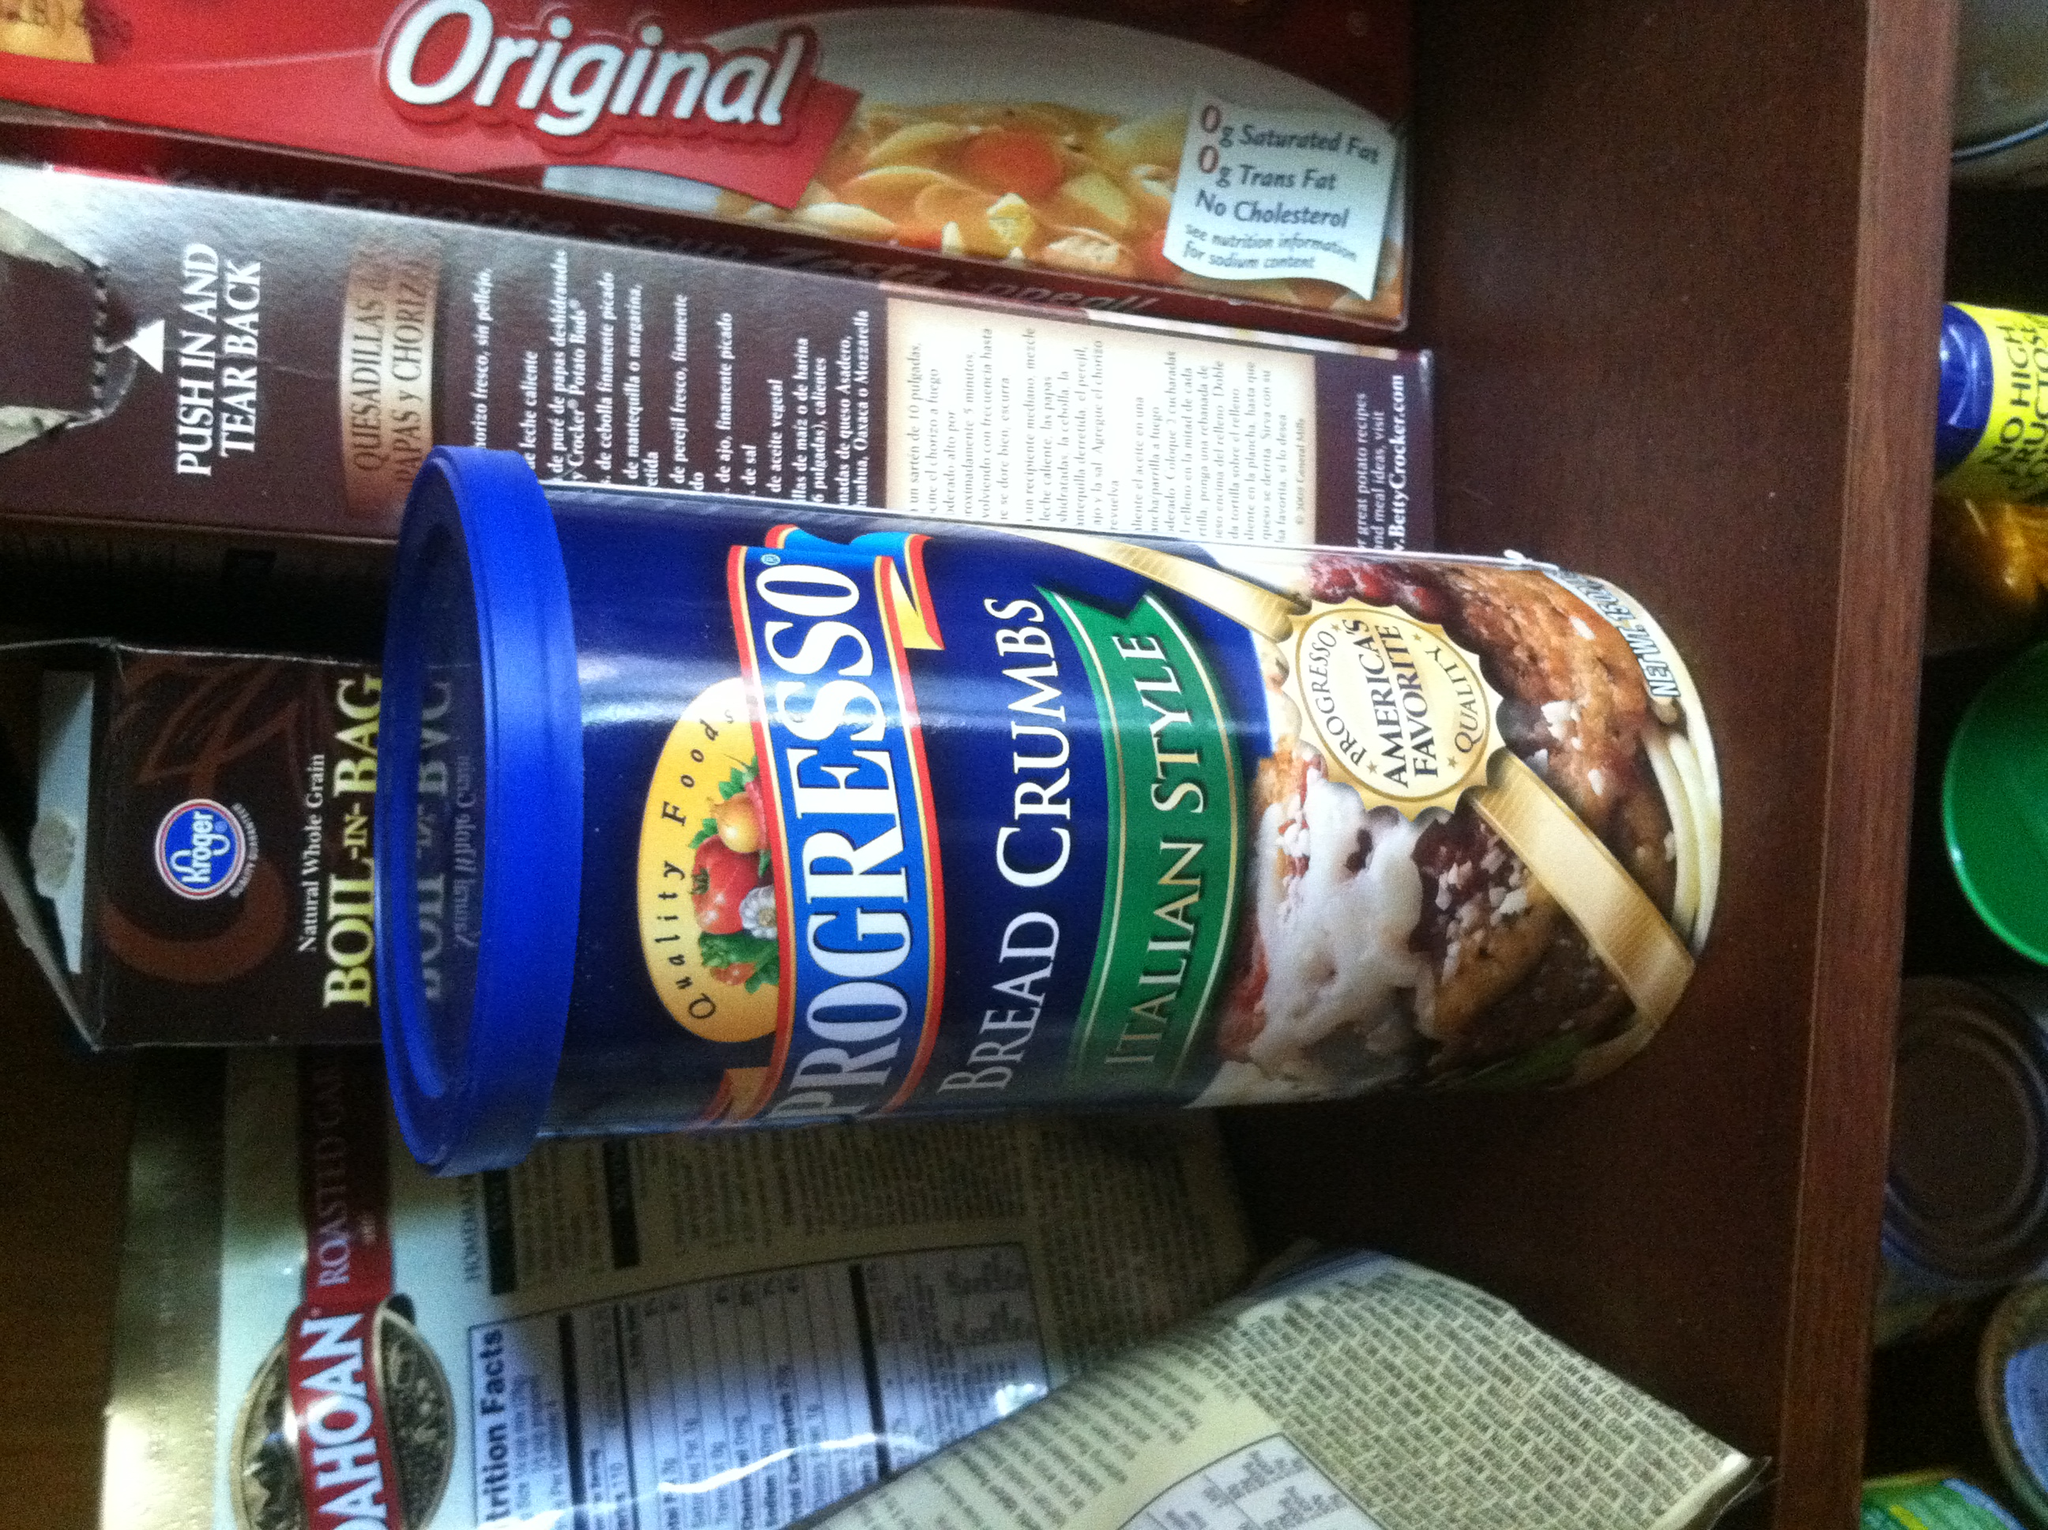If you were to imagine a story based on the items in this pantry, what would it be? In a quiet suburban kitchen, nestled within a modest cupboard, a collection of pantry items lived in harmony. There were Progresso Bread Crumbs, the wise elder, full of stories about grand Italian feasts. The box of Original macaroni and cheese was the cheerful joker, always ready to bring comfort and warmth. The Kroger Boil-in-Bag Brown Rice, the practical and straightforward hero, was always dependable and hearty. And there was the Mahatma bag of roasted grains, an exotic traveler from distant lands. One evening, as the family slept soundly, the pantry was visited by a tiny, curious kitchen fairy named Sprig. She flitted about, casting her curious gaze on each item, hoping to bring them to life for one magical night. Sprig waved her wand sprinkled with stardust, and in an instant, the pantry came alive with a warm glow. What happened next in this magical story? Sprig watched in delight as the pantry items awoke. Progresso Bread Crumbs began to hum an old Italian tune, filling the room with the scent of basil and oregano. The Original macaroni and cheese burst into laughter, the box spinning in excitement, glowing a golden hue. The Kroger Boil-in-Bag Brown Rice stood tall and bow, introducing itself formally to the Mahatma roasted grains, which responded with tales of exotic markets and ancient recipes. Sprig, with a clap of her tiny hands, called them together, suggesting they create a communal dish to symbolize their newfound friendship. The pantry items eagerly gathered their best qualities: the bread crumbs offering their crunchy texture, the macaroni and cheese bringing its creamy comfort, the brown rice contributing a hearty base, and the roasted grains adding a unique, nutty flavor. Sprig mixed them all together in a large pot, adding a sprinkle of fairy magic, and by morning, the kitchen was filled with the aroma of a dish that told a story of unity and friendship. When the family awoke, they found the magical dish on the kitchen counter, a symbol of the pantry items’ nightly adventure, and shared it together, feeling the warmth and love infused in every bite. 